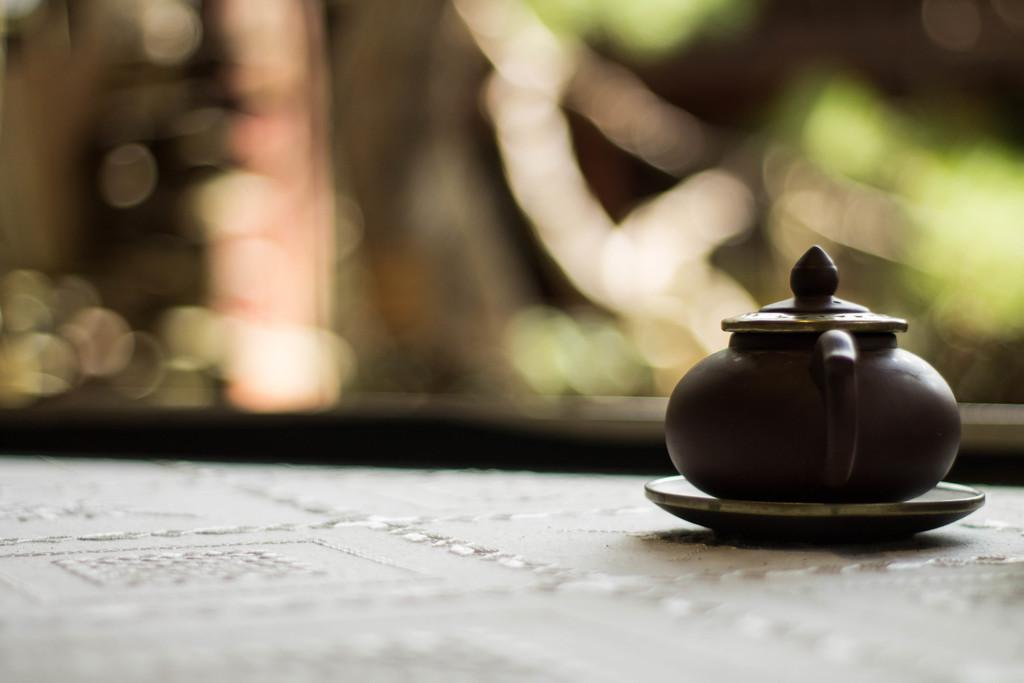What object is the main focus of the image? There is a black kettle in the image. Where is the kettle located? The kettle is on a table. Can you describe the background of the image? The background of the image is blurry. What type of skin is visible on the kettle in the image? There is no skin visible on the kettle in the image; it is a black kettle made of metal or another material. 